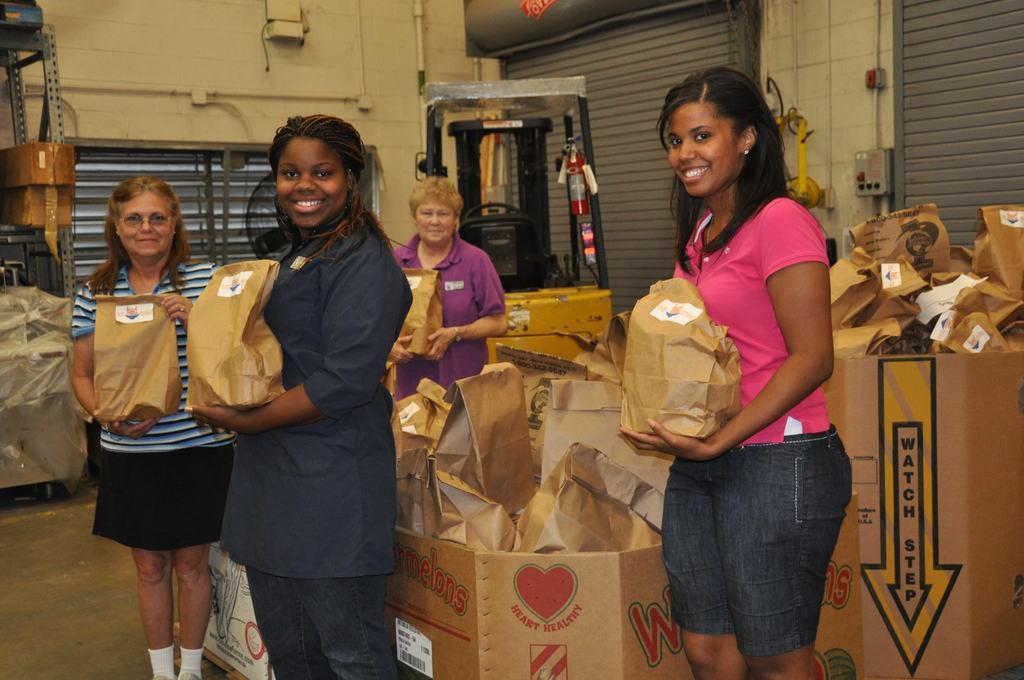Could you give a brief overview of what you see in this image? In this image, there are a few people holding some objects. We can see some cardboard boxes with paper bags. We can see the ground. We can see some shelves with objects on the left. We can also see some black colored objects. We can see the wall with shutters and some objects. 